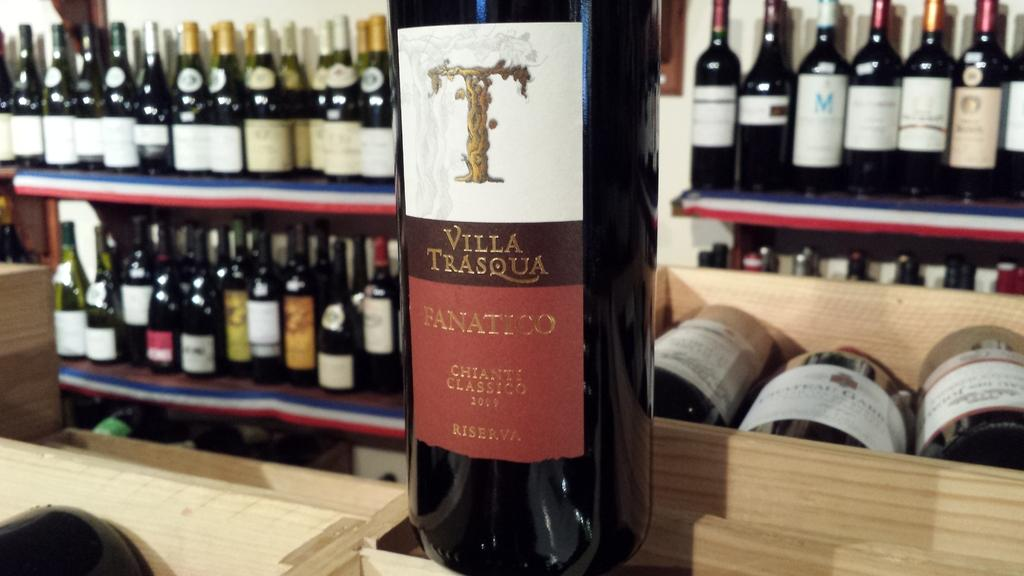<image>
Render a clear and concise summary of the photo. the word Fanatico that is on a beer bottle 